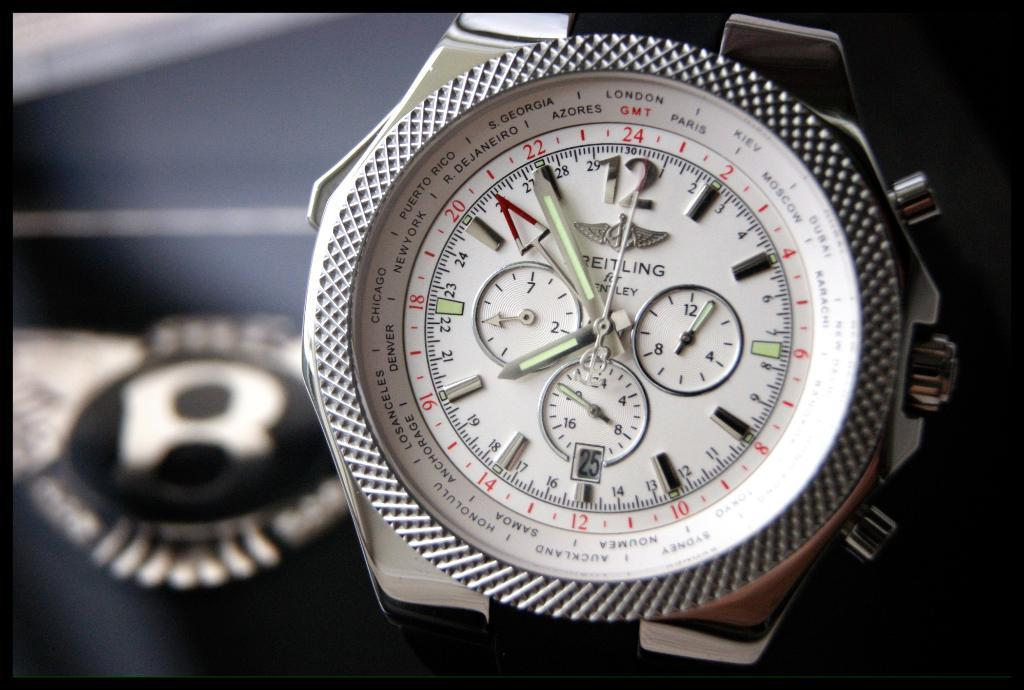Provide a one-sentence caption for the provided image. Black and silver watch that is includes the time and London. 